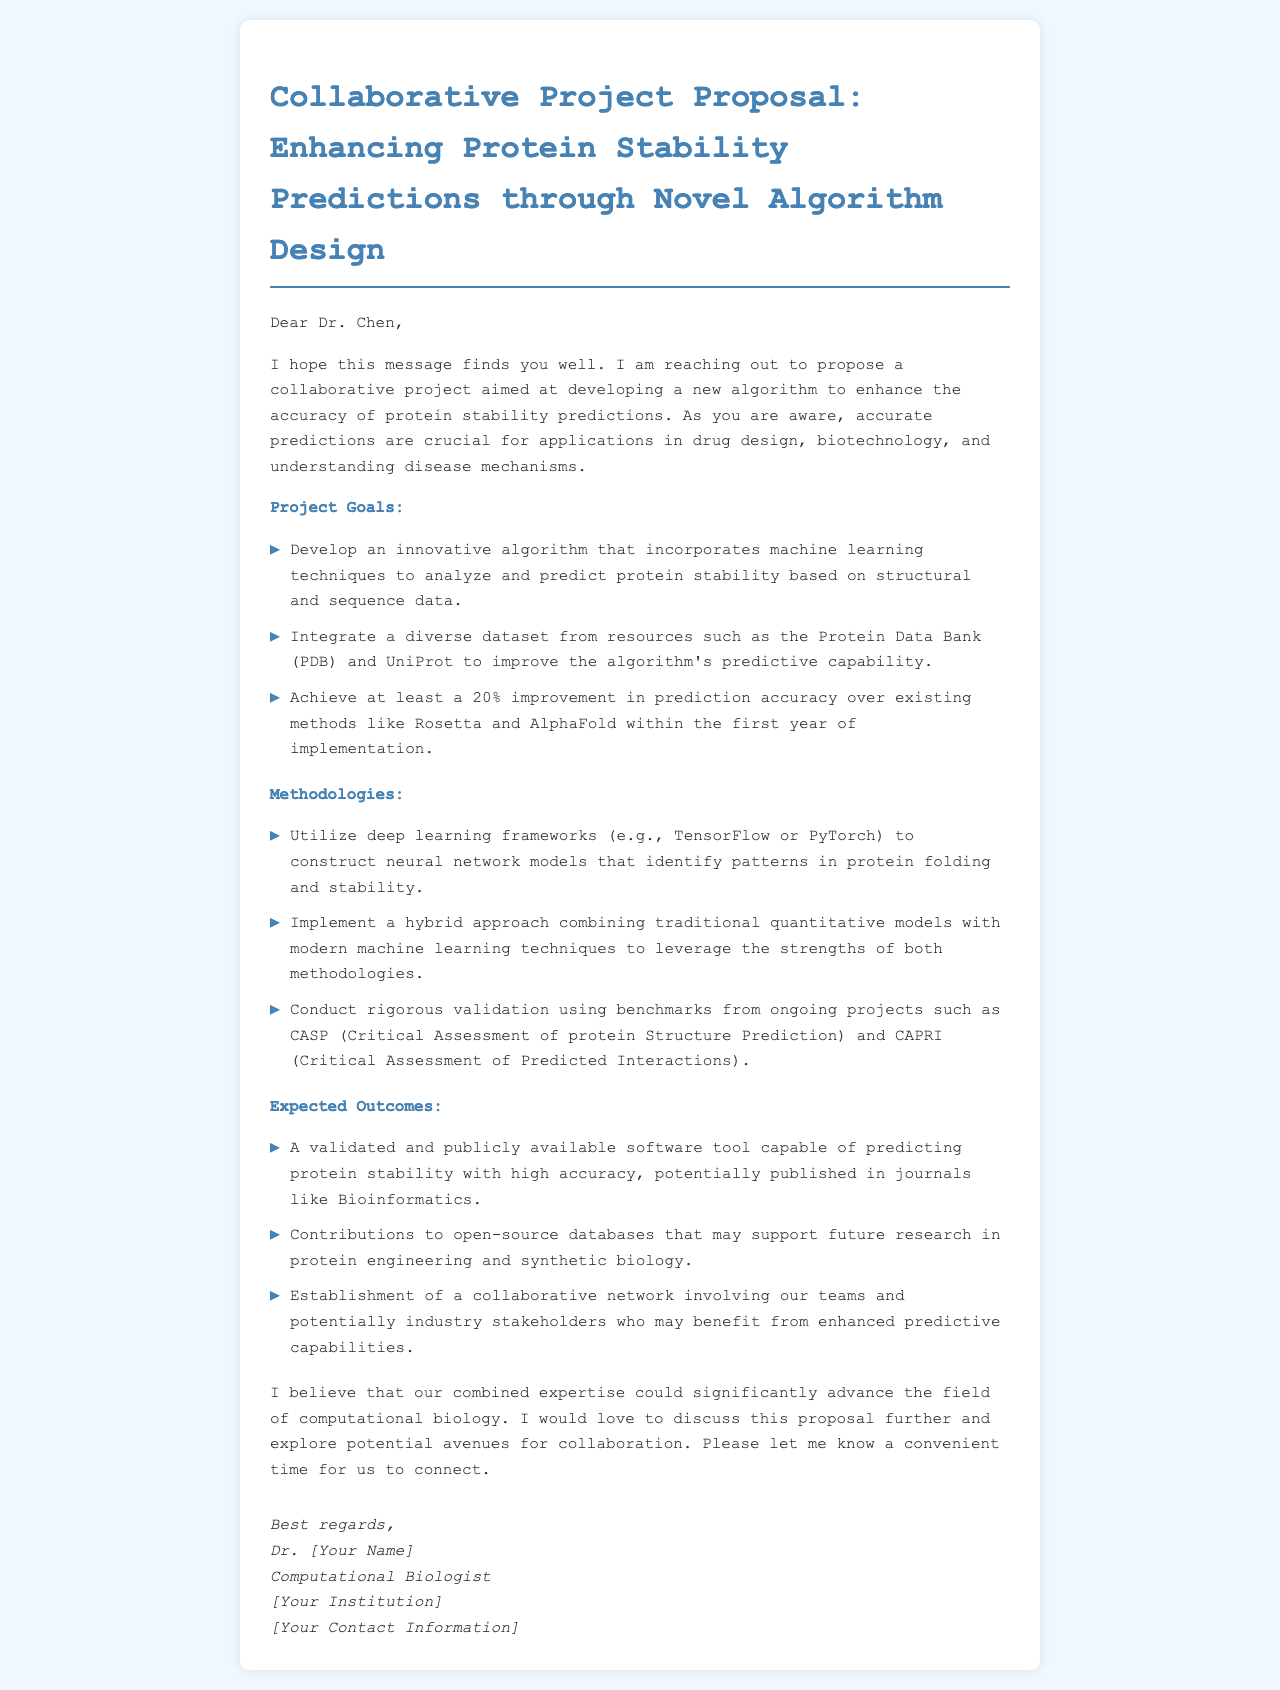What is the title of the project proposal? The title of the project proposal is explicitly stated at the beginning of the document.
Answer: Enhancing Protein Stability Predictions through Novel Algorithm Design Who is the recipient of the email? The email begins with a greeting that specifies the recipient's name.
Answer: Dr. Chen What is the expected improvement in prediction accuracy? The proposal outlines a specific target for improvement in accuracy compared to existing methods.
Answer: 20% Which deep learning frameworks are mentioned for model construction? The methodologies section lists specific frameworks that will be utilized for constructing neural network models.
Answer: TensorFlow or PyTorch What is one of the expected outcomes related to software? The expected outcomes section mentions a specific type of software tool that will be developed.
Answer: A validated and publicly available software tool What collaborative network is aimed to be established? The email discusses the intention to form a specific type of network through collaboration.
Answer: A collaborative network involving our teams and potentially industry stakeholders What methodologies will be combined in the new algorithm? The methodologies section states the types of models that will be integrated to leverage strengths.
Answer: Traditional quantitative models with modern machine learning techniques What is the primary goal of this project? The main intention of the project is outlined in the goals section at the start of the proposal.
Answer: Develop an innovative algorithm that incorporates machine learning techniques 